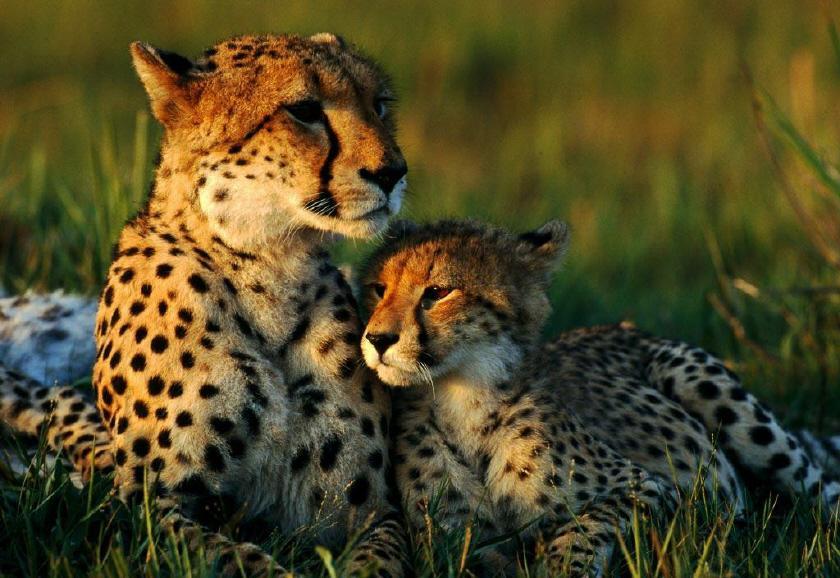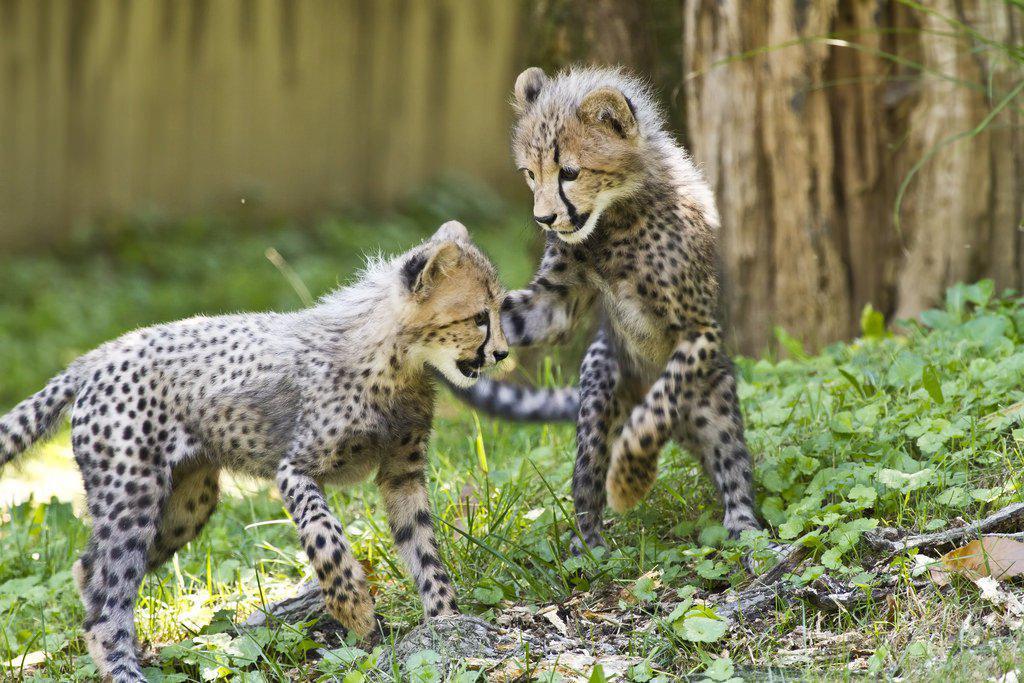The first image is the image on the left, the second image is the image on the right. Given the left and right images, does the statement "There are two cheetahs fighting with one of the cheetahs on its backside." hold true? Answer yes or no. No. The first image is the image on the left, the second image is the image on the right. For the images shown, is this caption "There is a single cheetah in the left image and two cheetahs in the right image." true? Answer yes or no. No. 